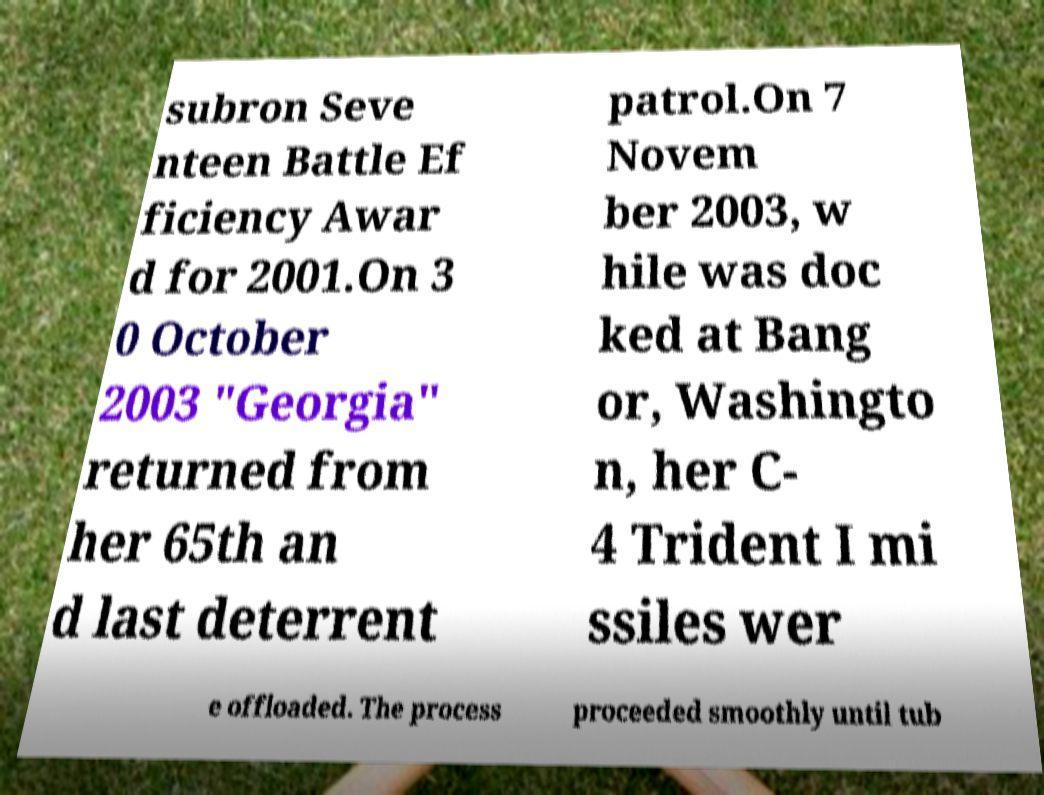Please identify and transcribe the text found in this image. subron Seve nteen Battle Ef ficiency Awar d for 2001.On 3 0 October 2003 "Georgia" returned from her 65th an d last deterrent patrol.On 7 Novem ber 2003, w hile was doc ked at Bang or, Washingto n, her C- 4 Trident I mi ssiles wer e offloaded. The process proceeded smoothly until tub 